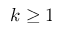Convert formula to latex. <formula><loc_0><loc_0><loc_500><loc_500>k \geq 1</formula> 